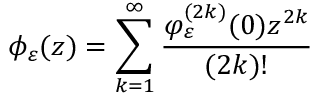Convert formula to latex. <formula><loc_0><loc_0><loc_500><loc_500>\phi _ { \varepsilon } ( z ) = \sum _ { k = 1 } ^ { \infty } \frac { \varphi _ { \varepsilon } ^ { ( 2 k ) } ( 0 ) z ^ { 2 k } } { ( 2 k ) ! }</formula> 